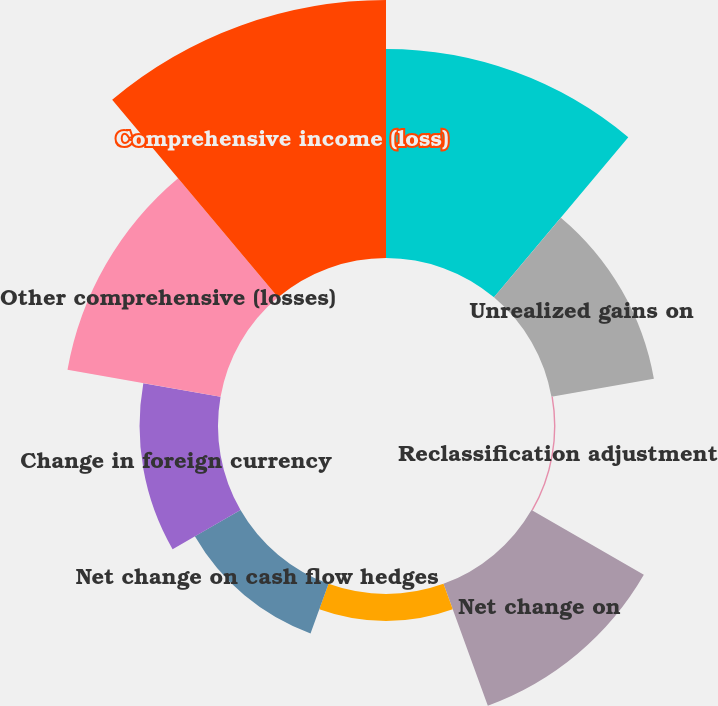<chart> <loc_0><loc_0><loc_500><loc_500><pie_chart><fcel>Net income (loss)<fcel>Unrealized gains on<fcel>Reclassification adjustment<fcel>Net change on<fcel>Unrealized (losses) gain on<fcel>Net change on cash flow hedges<fcel>Change in foreign currency<fcel>Other comprehensive (losses)<fcel>Comprehensive income (loss)<nl><fcel>20.57%<fcel>10.24%<fcel>0.14%<fcel>12.77%<fcel>2.67%<fcel>5.19%<fcel>7.72%<fcel>15.3%<fcel>25.4%<nl></chart> 